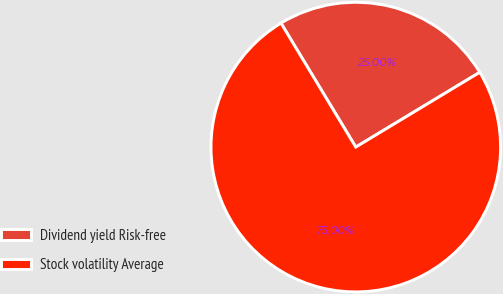Convert chart. <chart><loc_0><loc_0><loc_500><loc_500><pie_chart><fcel>Dividend yield Risk-free<fcel>Stock volatility Average<nl><fcel>25.0%<fcel>75.0%<nl></chart> 